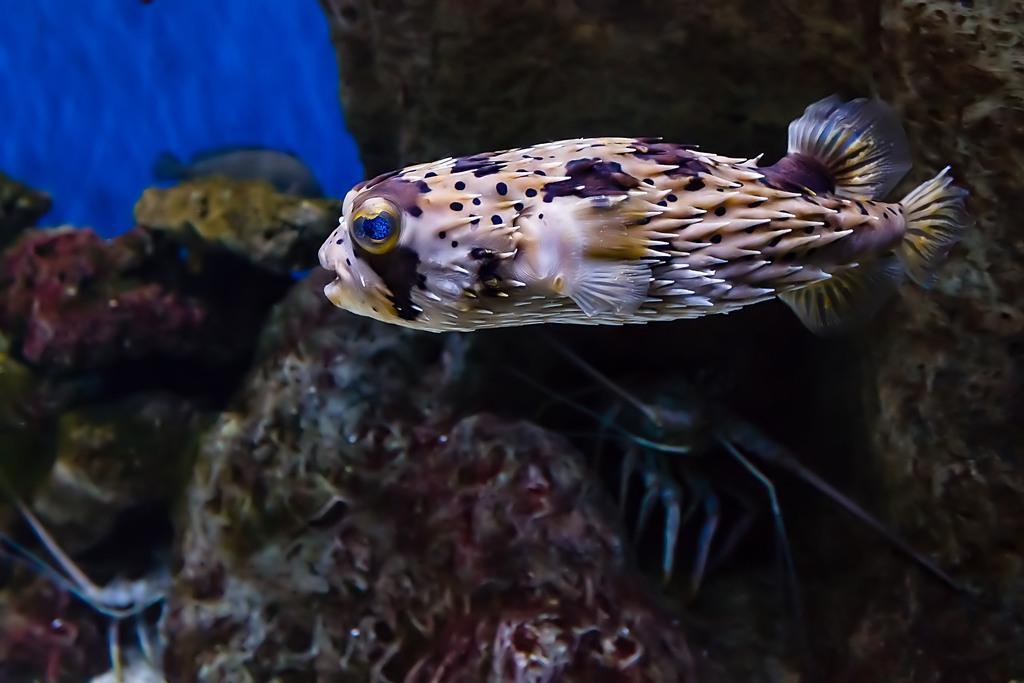Describe this image in one or two sentences. In this image I can see fish in the front. In the background I can see sea fungus and one more fish. On the top left side of this image I can see blue colour. 